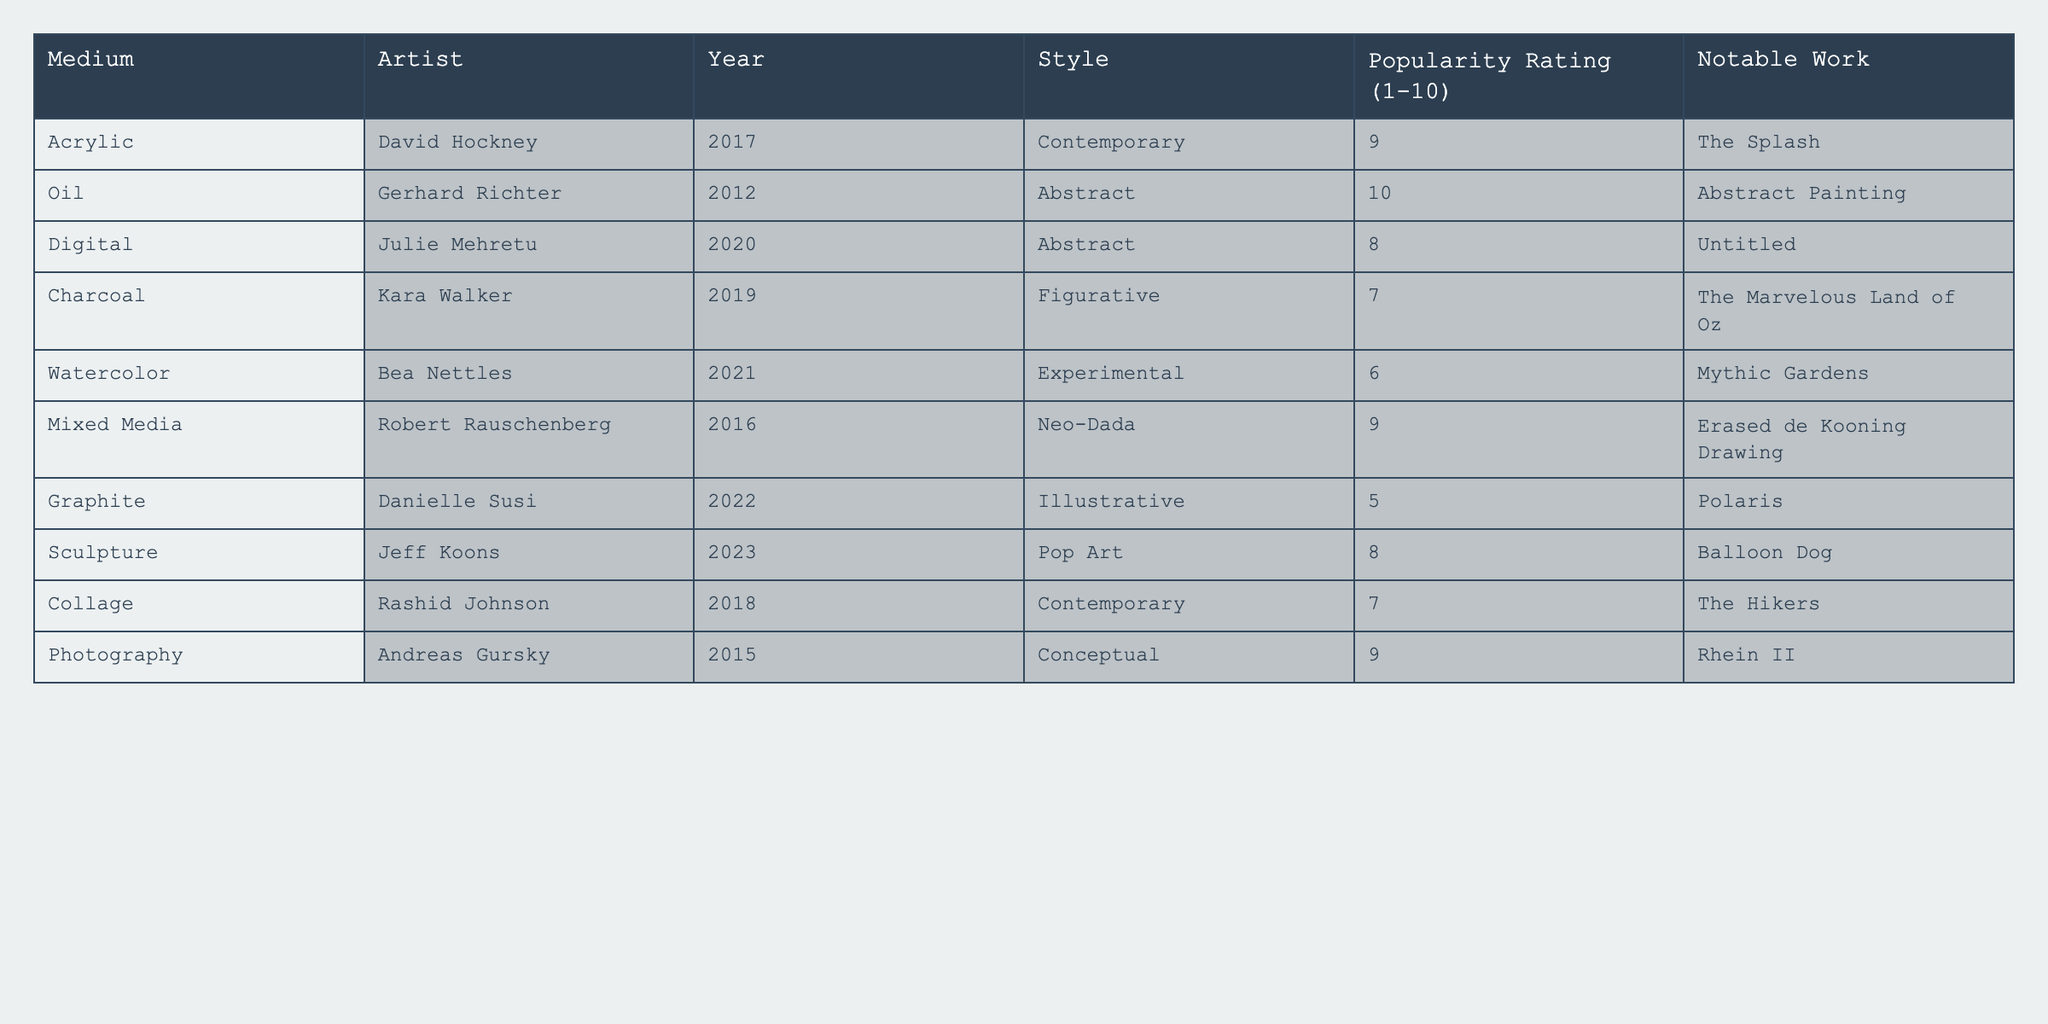What is the popularity rating of Gerhard Richter's work? The popularity rating of Gerhard Richter's work, which is an oil medium and created in 2012, is found in the table under the "Popularity Rating" column for his entry. It states that the rating is 10.
Answer: 10 Which artist used watercolor as their medium? By scanning the "Medium" column in the table, Bea Nettles is identified as the artist who used watercolor, as her name appears in the same row under that medium.
Answer: Bea Nettles What is the notable work of the artist who used mixed media? In the "Notable Work" column for Robert Rauschenberg, who is the artist associated with mixed media, the entry states "Erased de Kooning Drawing."
Answer: Erased de Kooning Drawing Which medium has the highest popularity rating? Looking at the "Popularity Rating" column, we find the highest value is 10, which corresponds to the oil medium used by Gerhard Richter.
Answer: Oil What is the average popularity rating of the artworks listed in the table? To find the average, we add the popularity ratings (9 + 10 + 8 + 7 + 6 + 9 + 5 + 8 + 7 + 9) = 78. There are 10 ratings, so we divide by 10: 78/10 = 7.8.
Answer: 7.8 Is there an artist using charcoal with a popularity rating above 5? The artist Kara Walker uses charcoal, and her popularity rating is 7, which is indeed above 5. Thus, the answer is confirmed as true.
Answer: Yes What medium is associated with Julie Mehretu and what is the popularity rating? Julie Mehretu is associated with the digital medium according to the "Medium" column, and her popularity rating is found in the corresponding row, which is 8.
Answer: Digital, 8 Which artist created a notable work in 2021 and what is the medium they used? By examining the "Year" column, Bea Nettles is the artist who created a work in 2021, and the corresponding "Medium" entry shows it was watercolor.
Answer: Bea Nettles, Watercolor What is the difference in popularity rating between the highest and lowest rated artworks? The highest rating is 10 (by Gerhard Richter) and the lowest is 5 (by Danielle Susi). The difference is 10 - 5 = 5.
Answer: 5 Which styles are represented by artists with a popularity rating of 9? There are two artists with a popularity rating of 9: David Hockney (Contemporary) and Robert Rauschenberg (Neo-Dada). Thus, both styles listed are Contemporary and Neo-Dada.
Answer: Contemporary, Neo-Dada 